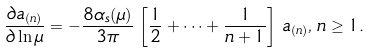Convert formula to latex. <formula><loc_0><loc_0><loc_500><loc_500>\frac { \partial a _ { ( n ) } } { \partial \ln \mu } = - \frac { 8 \alpha _ { s } ( \mu ) } { 3 \pi } \, \left [ \frac { 1 } { 2 } + \dots + \frac { 1 } { n + 1 } \right ] \, a _ { ( n ) } , \, n \geq 1 .</formula> 